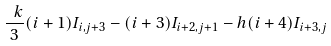<formula> <loc_0><loc_0><loc_500><loc_500>\frac { \ k } { 3 } ( i + 1 ) I _ { i , j + 3 } - ( i + 3 ) I _ { i + 2 , j + 1 } - h ( i + 4 ) I _ { i + 3 , j }</formula> 